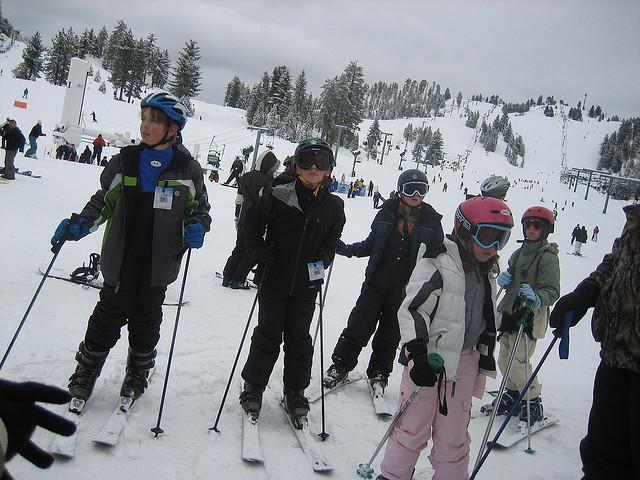How many of the people pictured are wearing skis?
Answer briefly. 5. Is the girl's clothing color coordinated?
Concise answer only. Yes. Is there a bus in the background?
Quick response, please. No. How many people are wearing glasses?
Quick response, please. 4. What sort of school is this?
Give a very brief answer. Ski. What color is the hat on the right?
Give a very brief answer. Pink. What does the man on the right have on his head?
Write a very short answer. Helmet. What number is the guy in front wearing?
Keep it brief. 30. How many people are looking at the camera?
Be succinct. 1. Why doesn't the girl in the blue helmet have goggles on?
Quick response, please. Protection. How many ski poles are visible?
Keep it brief. 9. Are their helmets the same color?
Be succinct. No. Who is taking the picture?
Quick response, please. Person. Is this an old picture?
Write a very short answer. No. Is everyone wearing sunglasses?
Give a very brief answer. No. How many kids wearing sunglasses?
Short answer required. 4. 